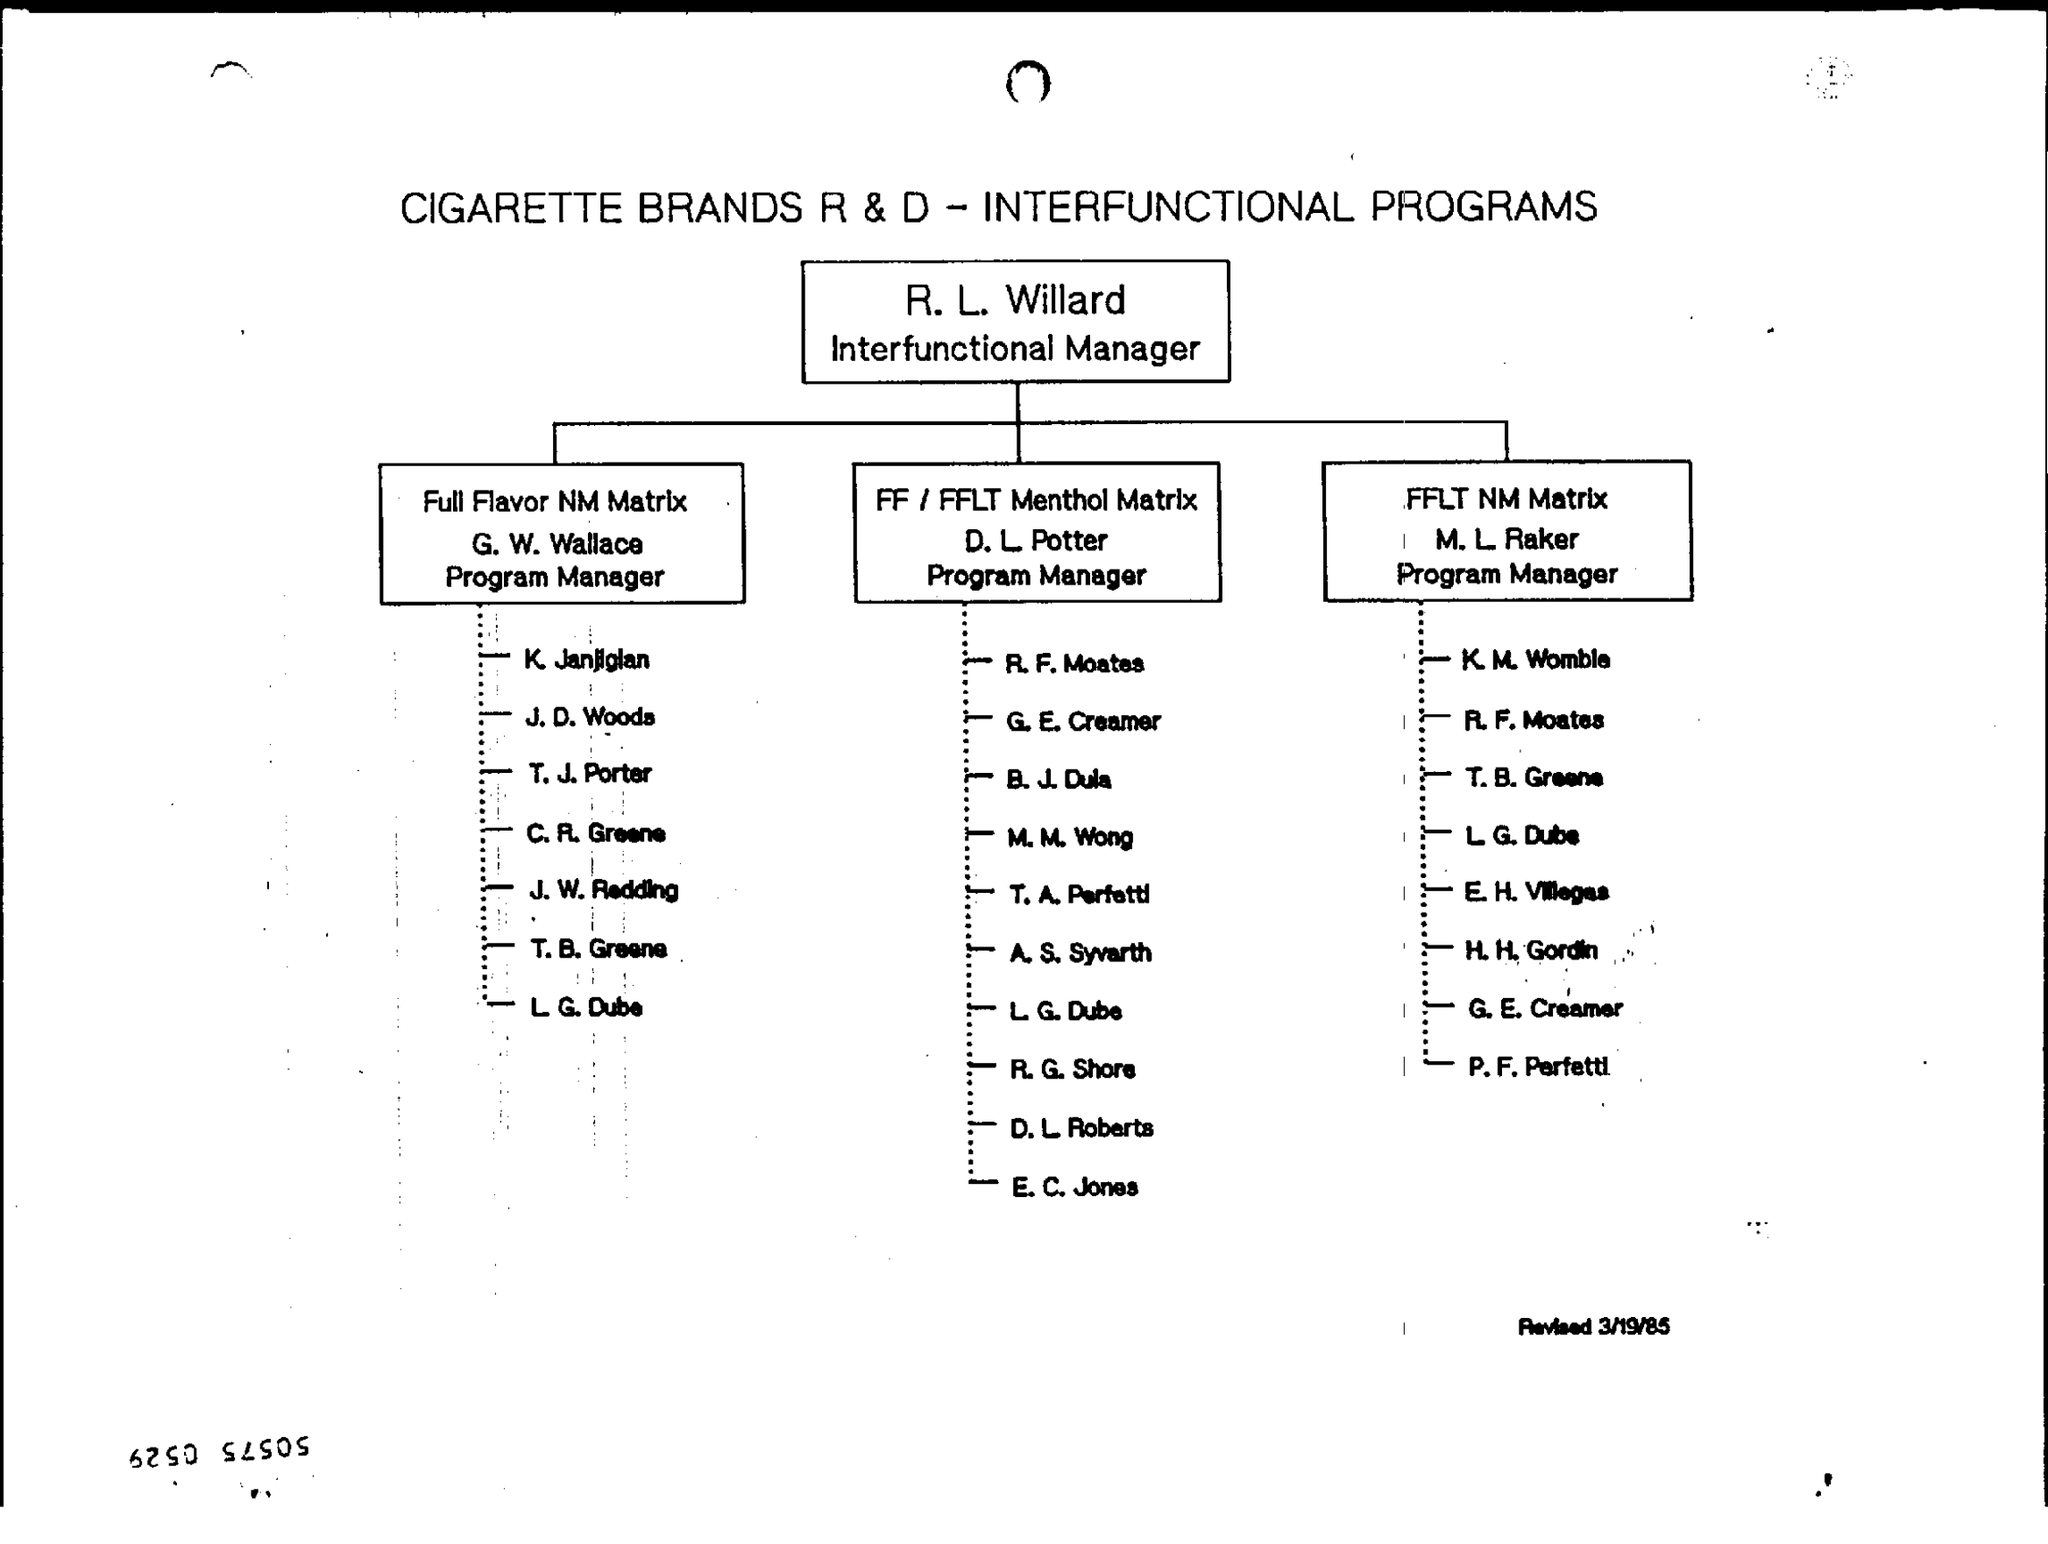What is the document title?
Offer a very short reply. CIGARETTE BRANDS R & D - INTERFUNCTIONAL PROGRAMS. What is the designation of R. L. Willard?
Your answer should be compact. Interfunctional Manager. Who is the Program Manager of Full Flavor NM Matrix?
Offer a terse response. G. W. Wallace. 